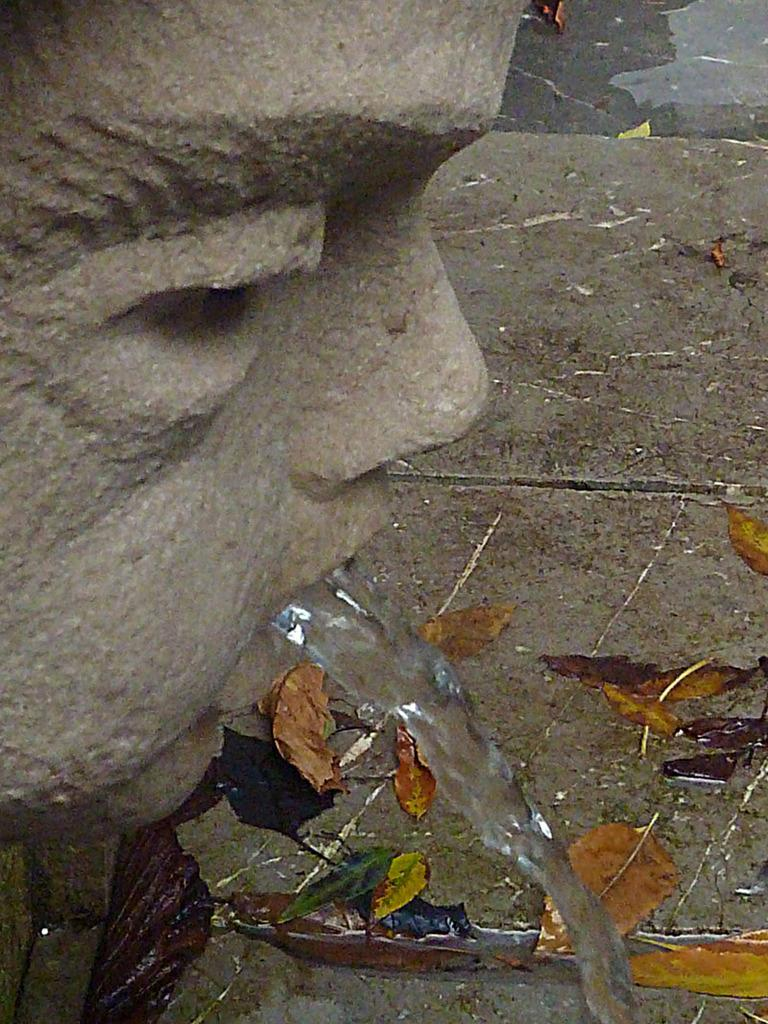What is the main subject in the image? There is a statue in the image. What can be seen around the statue? Water is visible from the statue in the image. What type of cookware is being used by the cook in the image? There is no cook or cookware present in the image; it features a statue and water. How many volleyballs can be seen in the image? There are no volleyballs present in the image; it features a statue and water. 